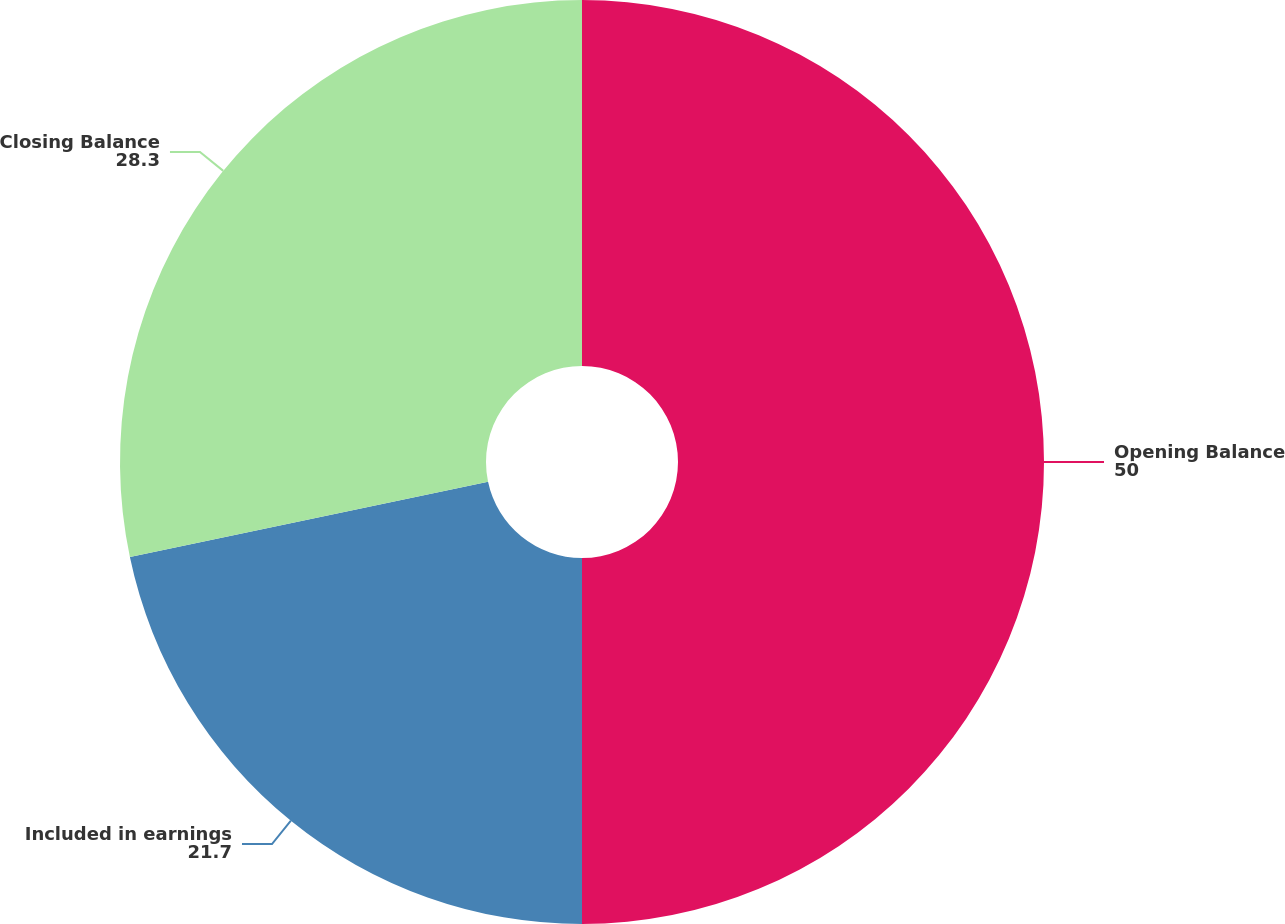Convert chart. <chart><loc_0><loc_0><loc_500><loc_500><pie_chart><fcel>Opening Balance<fcel>Included in earnings<fcel>Closing Balance<nl><fcel>50.0%<fcel>21.7%<fcel>28.3%<nl></chart> 